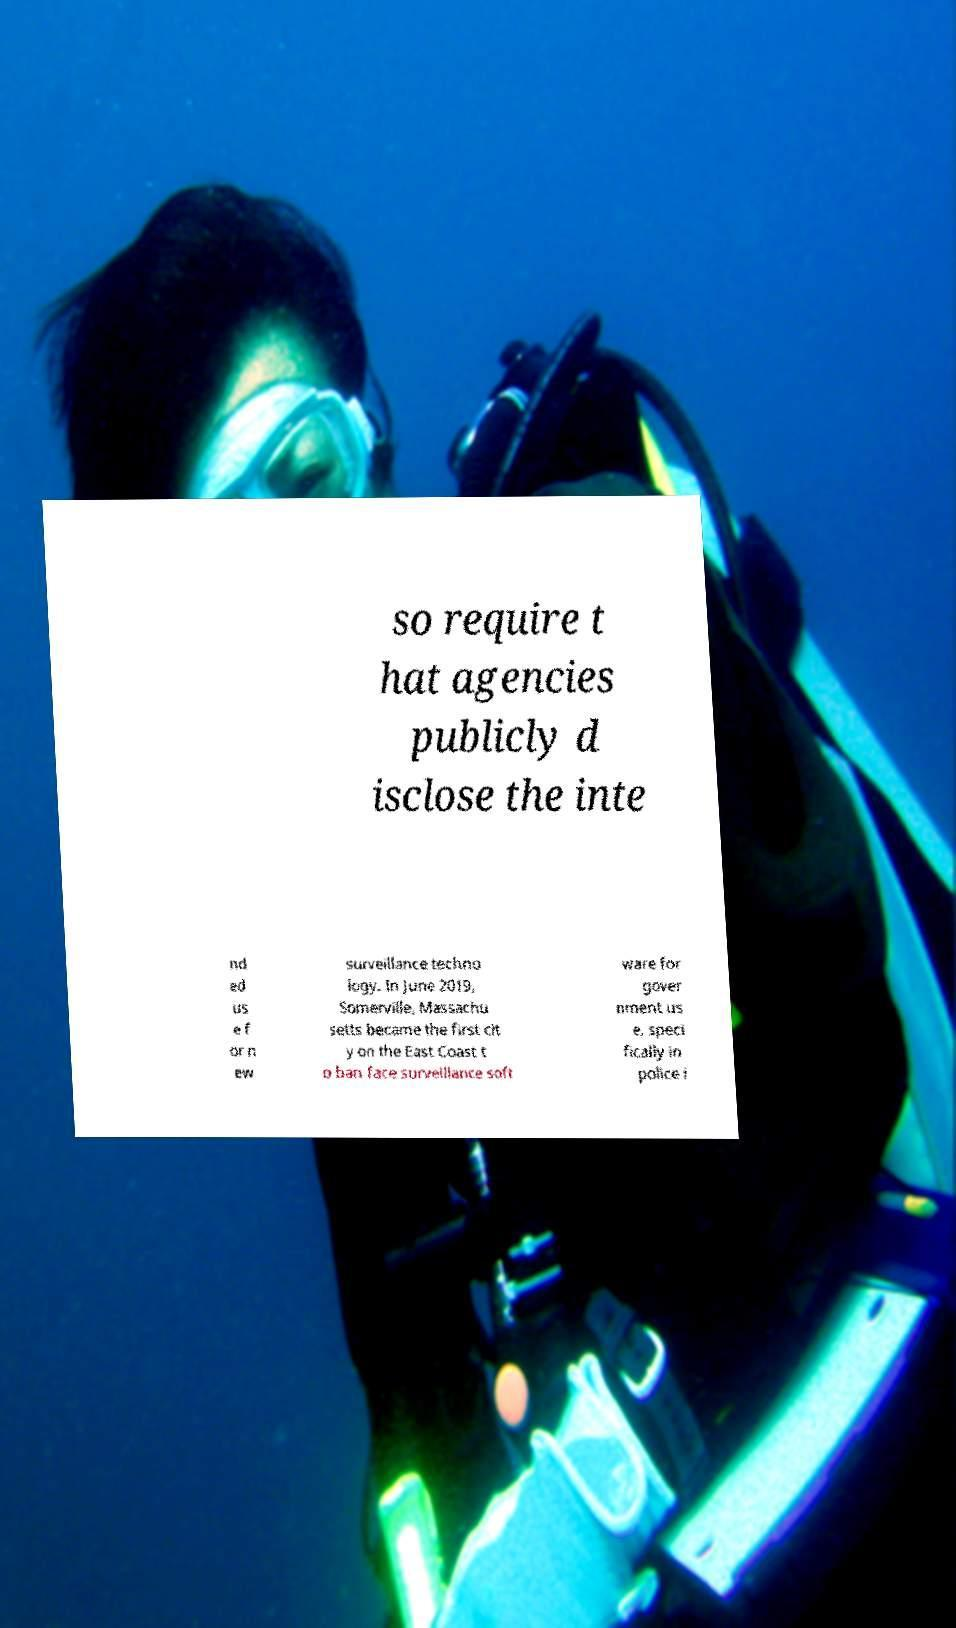Please read and relay the text visible in this image. What does it say? so require t hat agencies publicly d isclose the inte nd ed us e f or n ew surveillance techno logy. In June 2019, Somerville, Massachu setts became the first cit y on the East Coast t o ban face surveillance soft ware for gover nment us e, speci fically in police i 